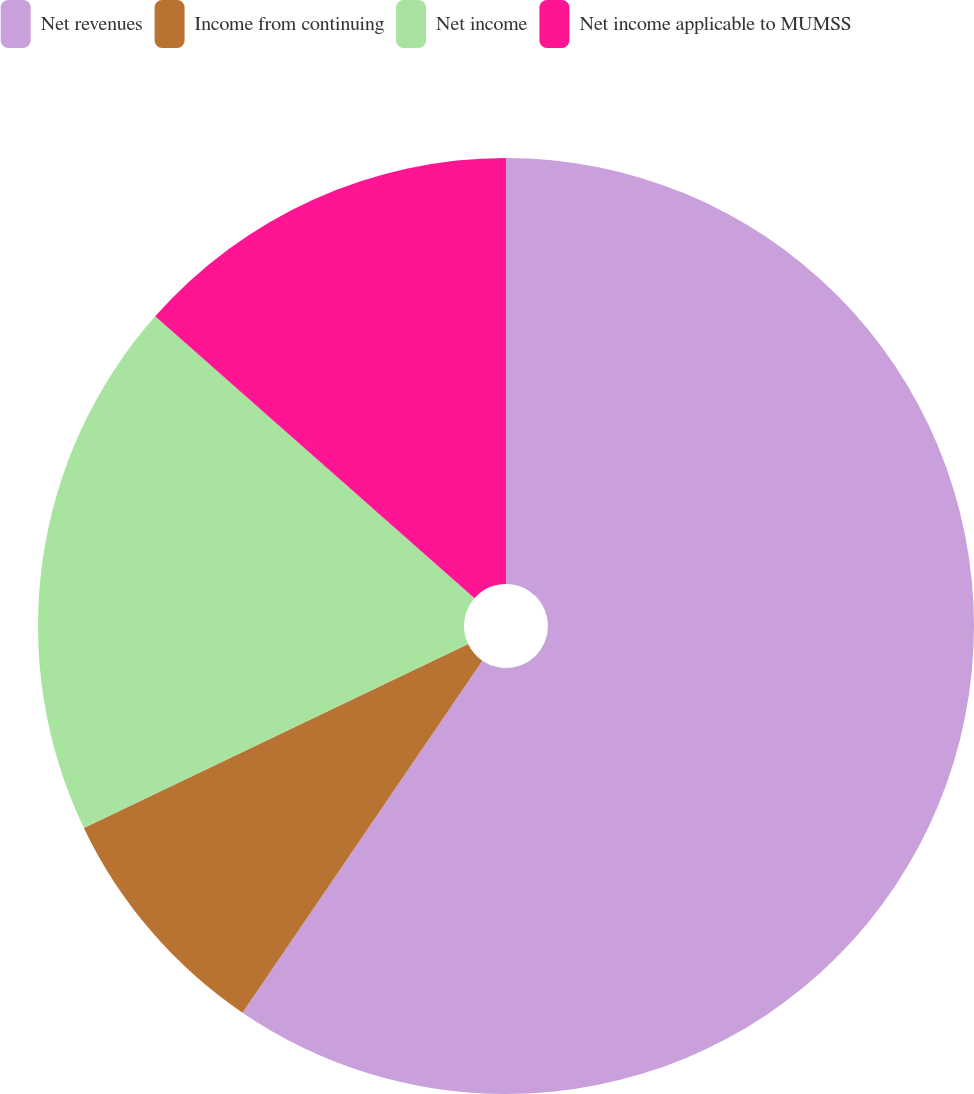Convert chart. <chart><loc_0><loc_0><loc_500><loc_500><pie_chart><fcel>Net revenues<fcel>Income from continuing<fcel>Net income<fcel>Net income applicable to MUMSS<nl><fcel>59.52%<fcel>8.38%<fcel>18.61%<fcel>13.49%<nl></chart> 